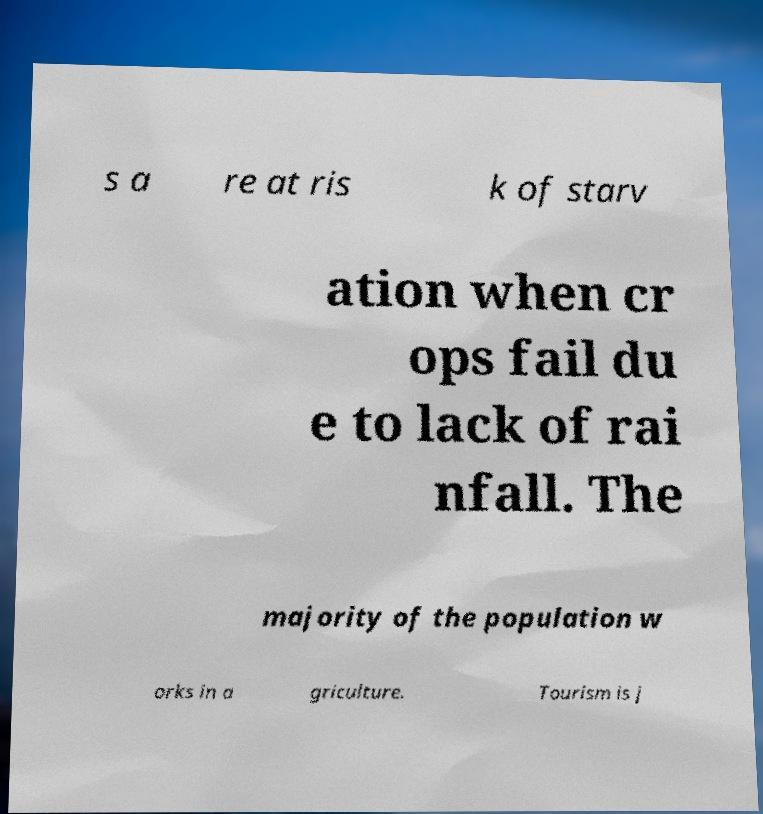What messages or text are displayed in this image? I need them in a readable, typed format. s a re at ris k of starv ation when cr ops fail du e to lack of rai nfall. The majority of the population w orks in a griculture. Tourism is j 